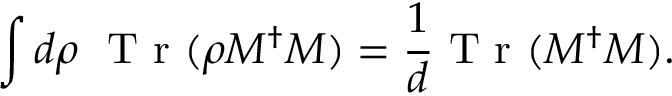Convert formula to latex. <formula><loc_0><loc_0><loc_500><loc_500>\int d \rho \, T r ( \rho M ^ { \dagger } M ) = \frac { 1 } { d } T r ( M ^ { \dagger } M ) .</formula> 